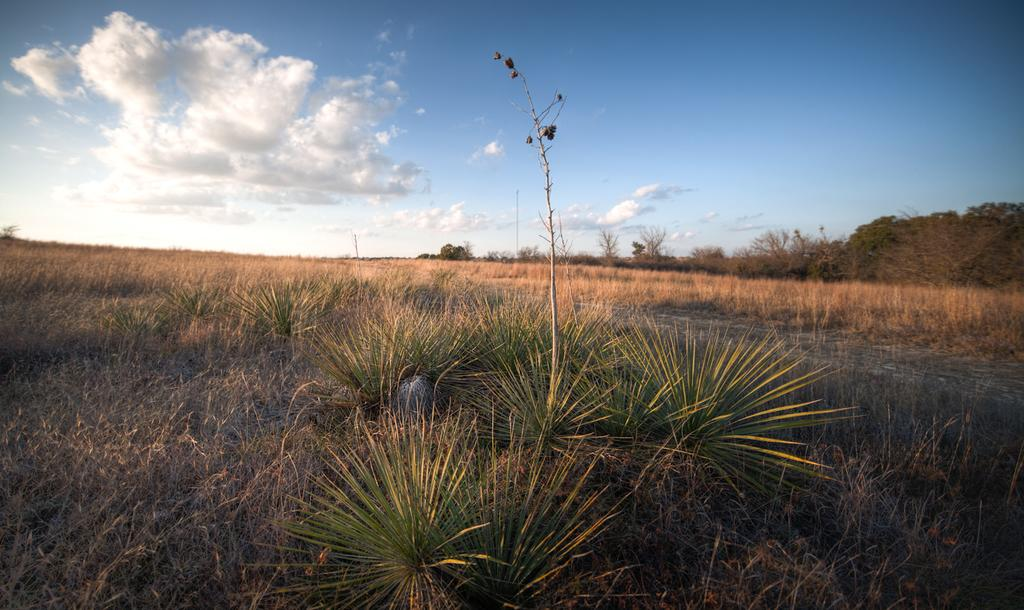What type of vegetation can be seen in the image? There is grass in the image. What other natural elements are present in the image? There are trees in the image. How would you describe the sky in the image? The sky is cloudy in the image. What type of muscle is being exercised by the trees in the image? There is no indication in the image that the trees are exercising any muscles, as trees do not have muscles. 